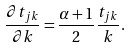Convert formula to latex. <formula><loc_0><loc_0><loc_500><loc_500>\frac { \partial t _ { j k } } { \partial k } = \frac { \alpha + 1 } { 2 } \frac { t _ { j k } } { k } .</formula> 